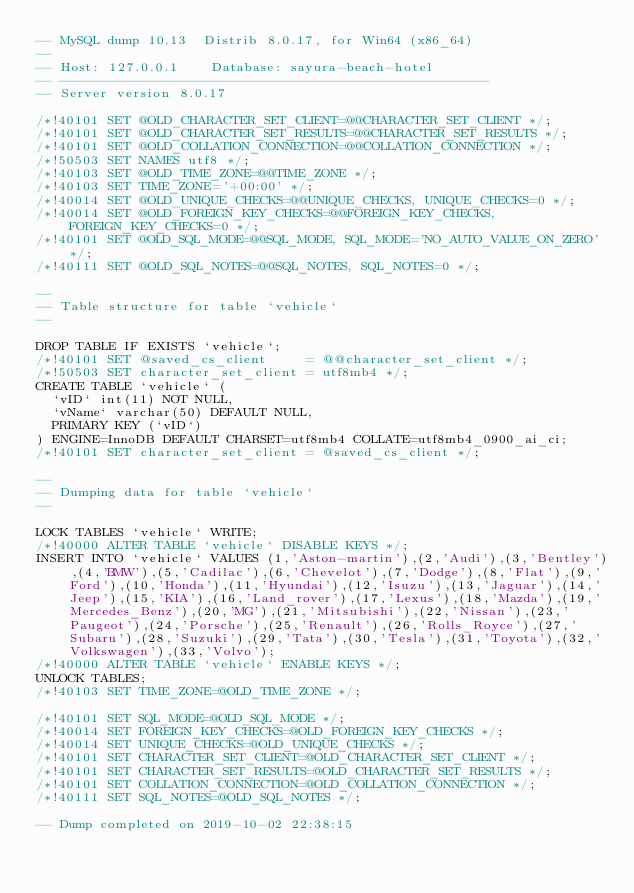<code> <loc_0><loc_0><loc_500><loc_500><_SQL_>-- MySQL dump 10.13  Distrib 8.0.17, for Win64 (x86_64)
--
-- Host: 127.0.0.1    Database: sayura-beach-hotel
-- ------------------------------------------------------
-- Server version	8.0.17

/*!40101 SET @OLD_CHARACTER_SET_CLIENT=@@CHARACTER_SET_CLIENT */;
/*!40101 SET @OLD_CHARACTER_SET_RESULTS=@@CHARACTER_SET_RESULTS */;
/*!40101 SET @OLD_COLLATION_CONNECTION=@@COLLATION_CONNECTION */;
/*!50503 SET NAMES utf8 */;
/*!40103 SET @OLD_TIME_ZONE=@@TIME_ZONE */;
/*!40103 SET TIME_ZONE='+00:00' */;
/*!40014 SET @OLD_UNIQUE_CHECKS=@@UNIQUE_CHECKS, UNIQUE_CHECKS=0 */;
/*!40014 SET @OLD_FOREIGN_KEY_CHECKS=@@FOREIGN_KEY_CHECKS, FOREIGN_KEY_CHECKS=0 */;
/*!40101 SET @OLD_SQL_MODE=@@SQL_MODE, SQL_MODE='NO_AUTO_VALUE_ON_ZERO' */;
/*!40111 SET @OLD_SQL_NOTES=@@SQL_NOTES, SQL_NOTES=0 */;

--
-- Table structure for table `vehicle`
--

DROP TABLE IF EXISTS `vehicle`;
/*!40101 SET @saved_cs_client     = @@character_set_client */;
/*!50503 SET character_set_client = utf8mb4 */;
CREATE TABLE `vehicle` (
  `vID` int(11) NOT NULL,
  `vName` varchar(50) DEFAULT NULL,
  PRIMARY KEY (`vID`)
) ENGINE=InnoDB DEFAULT CHARSET=utf8mb4 COLLATE=utf8mb4_0900_ai_ci;
/*!40101 SET character_set_client = @saved_cs_client */;

--
-- Dumping data for table `vehicle`
--

LOCK TABLES `vehicle` WRITE;
/*!40000 ALTER TABLE `vehicle` DISABLE KEYS */;
INSERT INTO `vehicle` VALUES (1,'Aston-martin'),(2,'Audi'),(3,'Bentley'),(4,'BMW'),(5,'Cadilac'),(6,'Chevelot'),(7,'Dodge'),(8,'Flat'),(9,'Ford'),(10,'Honda'),(11,'Hyundai'),(12,'Isuzu'),(13,'Jaguar'),(14,'Jeep'),(15,'KIA'),(16,'Land_rover'),(17,'Lexus'),(18,'Mazda'),(19,'Mercedes_Benz'),(20,'MG'),(21,'Mitsubishi'),(22,'Nissan'),(23,'Paugeot'),(24,'Porsche'),(25,'Renault'),(26,'Rolls_Royce'),(27,'Subaru'),(28,'Suzuki'),(29,'Tata'),(30,'Tesla'),(31,'Toyota'),(32,'Volkswagen'),(33,'Volvo');
/*!40000 ALTER TABLE `vehicle` ENABLE KEYS */;
UNLOCK TABLES;
/*!40103 SET TIME_ZONE=@OLD_TIME_ZONE */;

/*!40101 SET SQL_MODE=@OLD_SQL_MODE */;
/*!40014 SET FOREIGN_KEY_CHECKS=@OLD_FOREIGN_KEY_CHECKS */;
/*!40014 SET UNIQUE_CHECKS=@OLD_UNIQUE_CHECKS */;
/*!40101 SET CHARACTER_SET_CLIENT=@OLD_CHARACTER_SET_CLIENT */;
/*!40101 SET CHARACTER_SET_RESULTS=@OLD_CHARACTER_SET_RESULTS */;
/*!40101 SET COLLATION_CONNECTION=@OLD_COLLATION_CONNECTION */;
/*!40111 SET SQL_NOTES=@OLD_SQL_NOTES */;

-- Dump completed on 2019-10-02 22:38:15
</code> 